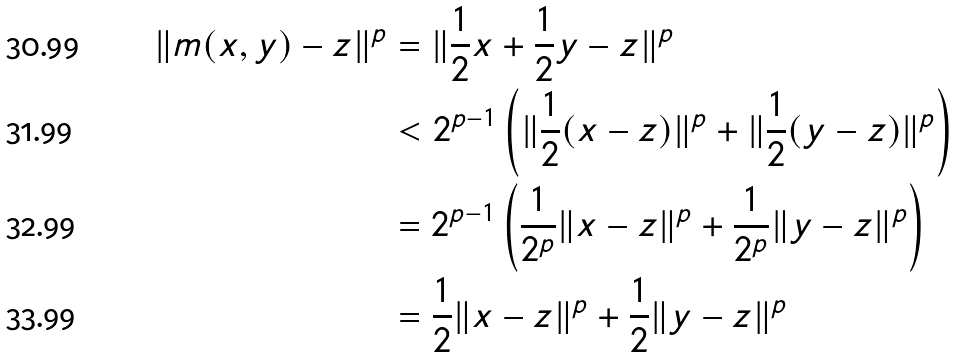<formula> <loc_0><loc_0><loc_500><loc_500>\| m ( x , y ) - z \| ^ { p } & = \| \frac { 1 } { 2 } x + \frac { 1 } { 2 } y - z \| ^ { p } \\ & < 2 ^ { p - 1 } \left ( \| \frac { 1 } { 2 } ( x - z ) \| ^ { p } + \| \frac { 1 } { 2 } ( y - z ) \| ^ { p } \right ) \\ & = 2 ^ { p - 1 } \left ( \frac { 1 } { 2 ^ { p } } \| x - z \| ^ { p } + \frac { 1 } { 2 ^ { p } } \| y - z \| ^ { p } \right ) \\ & = \frac { 1 } { 2 } \| x - z \| ^ { p } + \frac { 1 } { 2 } \| y - z \| ^ { p }</formula> 